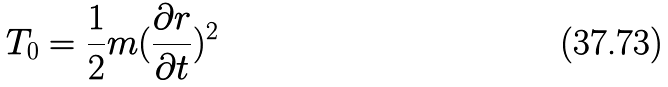<formula> <loc_0><loc_0><loc_500><loc_500>T _ { 0 } = \frac { 1 } { 2 } m ( \frac { \partial r } { \partial t } ) ^ { 2 }</formula> 